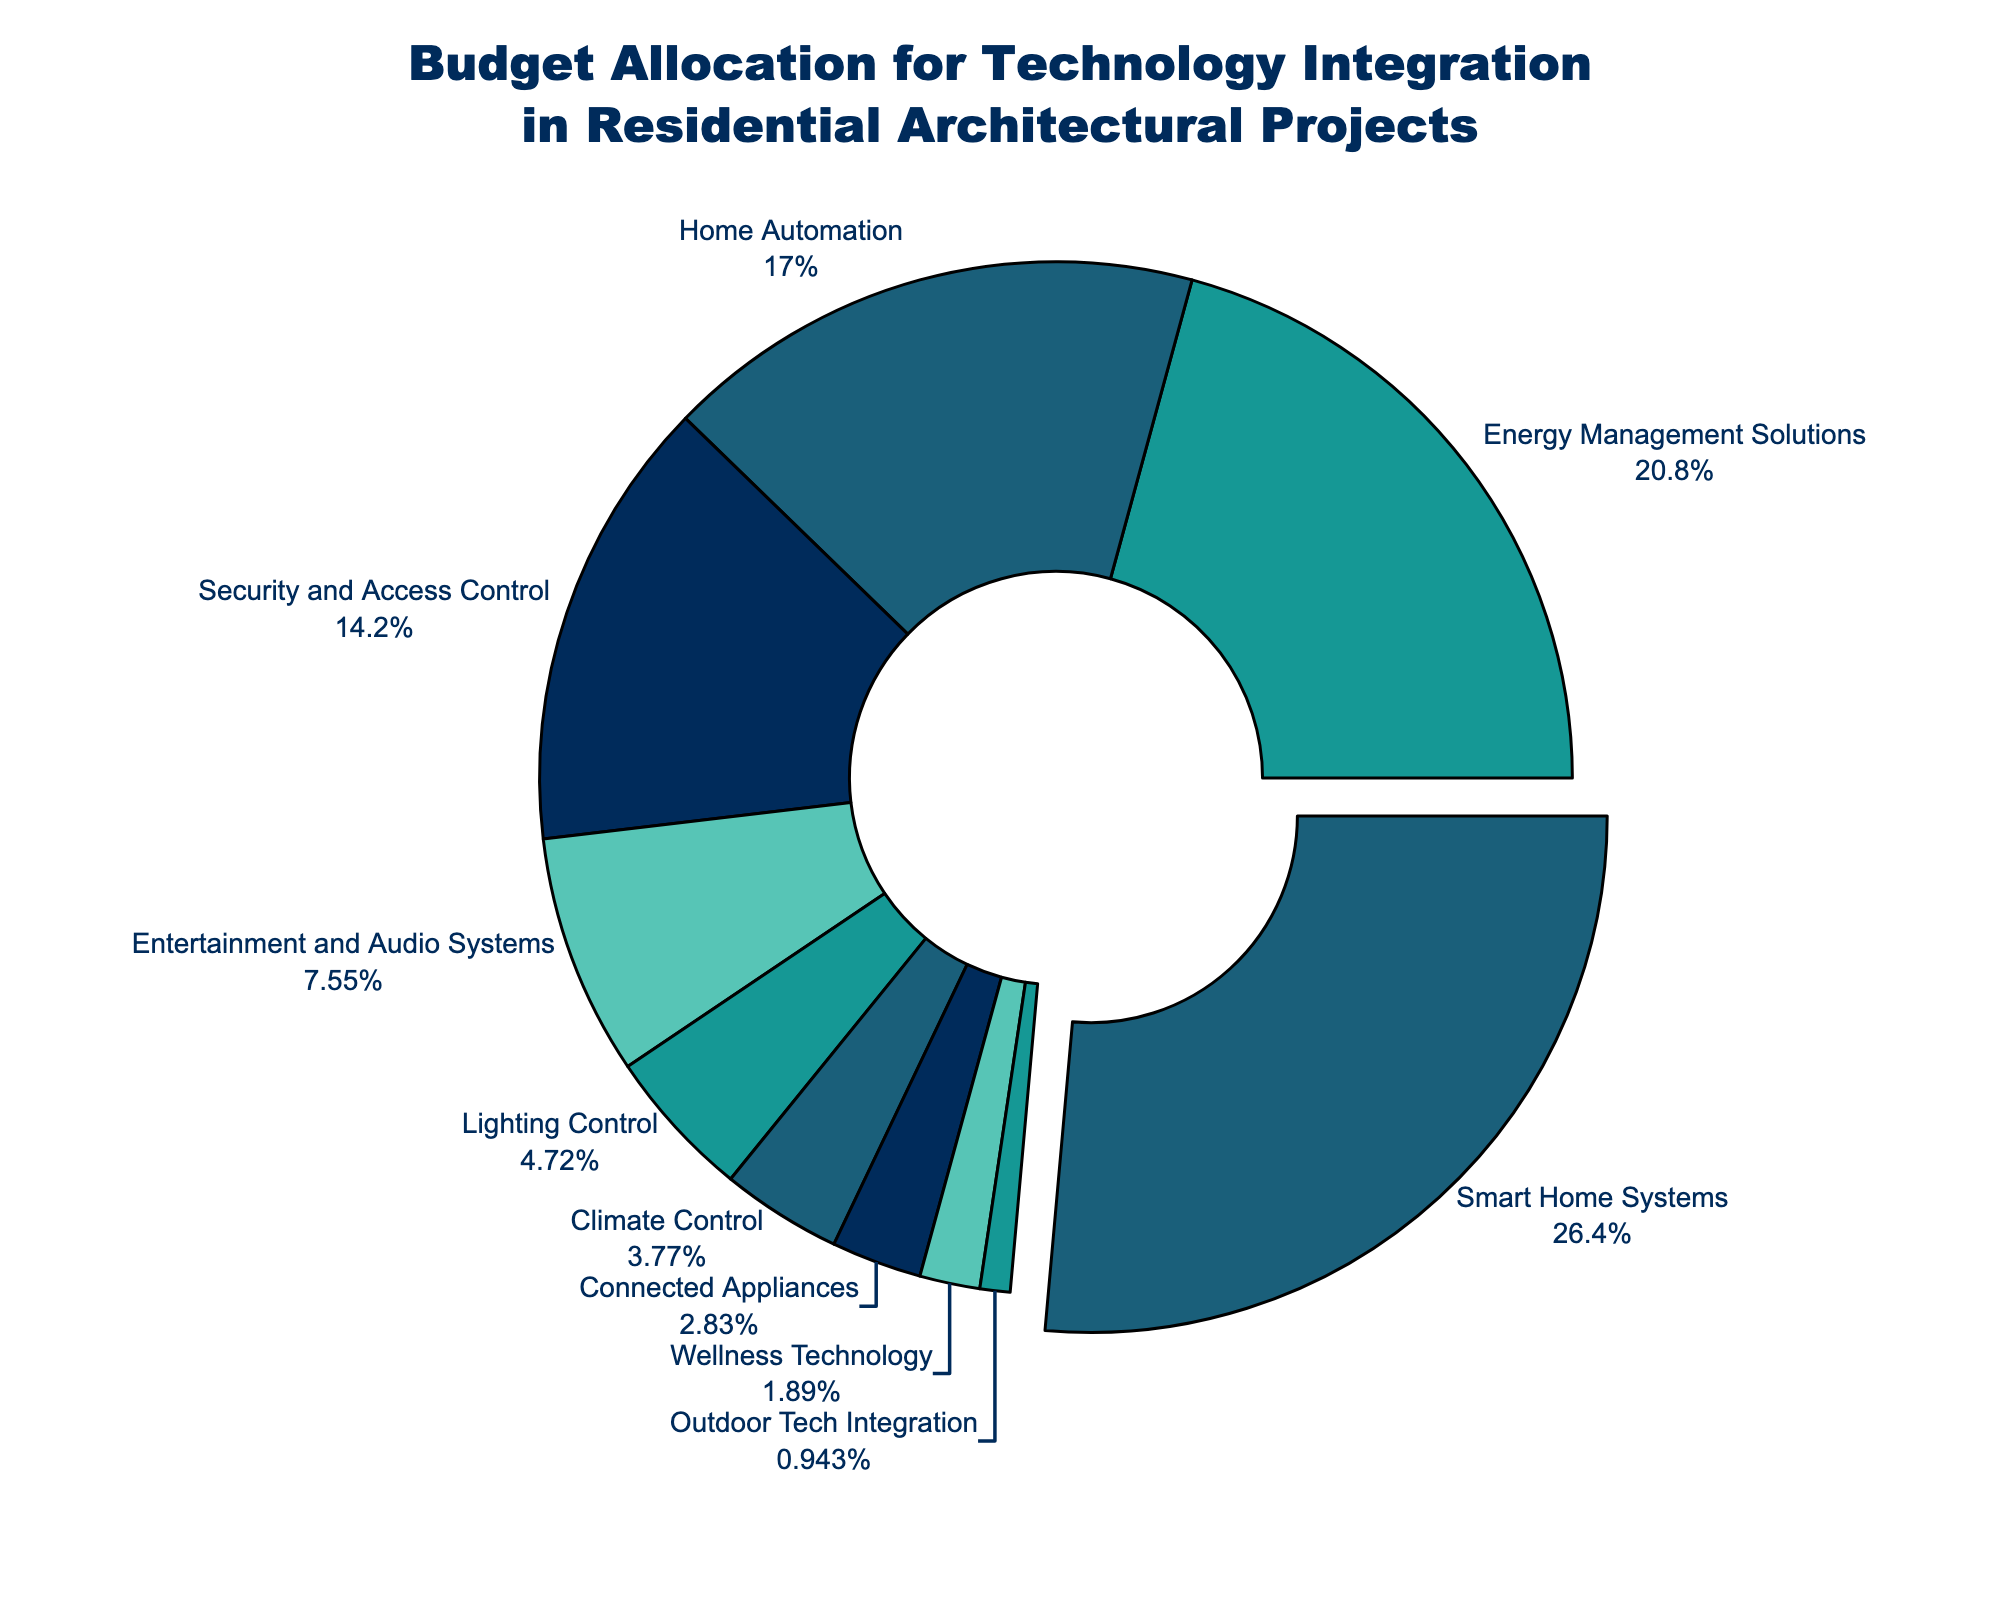Which category has the highest budget allocation? The category with the highest budget allocation is visually highlighted and has the largest segment in the pie chart.
Answer: Smart Home Systems How much more budget is allocated to Smart Home Systems compared to Connected Appliances? From the chart, Smart Home Systems have a 28% allocation while Connected Appliances have 3%. The difference is calculated as 28% - 3%.
Answer: 25% What is the combined budget allocation for Energy Management Solutions and Home Automation? To find the combined allocation, add the percentages from both categories: 22% (Energy Management Solutions) + 18% (Home Automation).
Answer: 40% Which categories have a budget allocation lower than 5%? Categories with segments smaller than 5% can be identified visually from the pie chart. These are Climate Control, Connected Appliances, Wellness Technology, and Outdoor Tech Integration.
Answer: Climate Control, Connected Appliances, Wellness Technology, Outdoor Tech Integration What is the average budget allocation across all categories? Add all percentage values and divide by the number of categories: (28 + 22 + 18 + 15 + 8 + 5 + 4 + 3 + 2 + 1) / 10. This results in 106 / 10.
Answer: 10.6% How does the budget allocation for Security and Access Control compare to Entertainment and Audio Systems? From the chart, Security and Access Control has a 15% allocation, while Entertainment and Audio Systems have 8%. Comparing these, Security and Access Control has a higher allocation.
Answer: Security and Access Control has a higher allocation What proportion of the total budget is allocated to the three least funded categories combined? Summing the percentages of the three smallest segments, which are Wellness Technology, Connected Appliances, and Outdoor Tech Integration: 2% + 3% + 1%.
Answer: 6% How many categories have a budget allocation greater than or equal to 10%? By examining the chart, categories with segments of 10% or larger are Smart Home Systems, Energy Management Solutions, Home Automation, and Security and Access Control.
Answer: 4 What percentage of the budget is allocated to lighting-related technologies (Lighting Control and Climate Control combined)? Add the percentages of Lighting Control and Climate Control from the chart: 5% + 4%.
Answer: 9% What is the total percentage allocated to Entertainment and Audio Systems, Lighting Control, and Climate Control combined? Summing the percentages from these three categories gives us: 8% (Entertainment and Audio Systems) + 5% (Lighting Control) + 4% (Climate Control).
Answer: 17% 